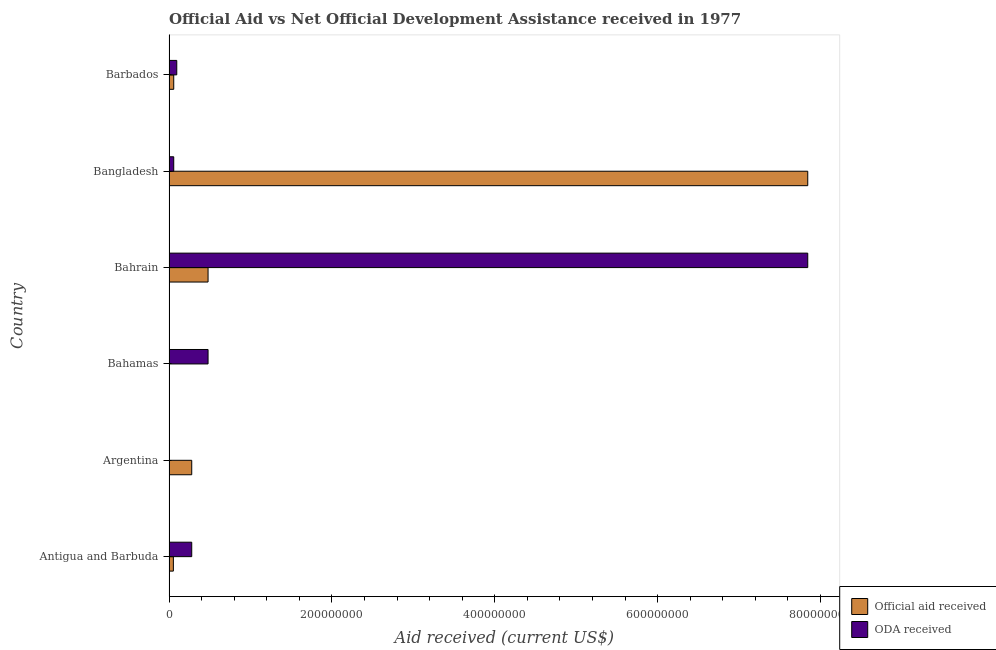How many different coloured bars are there?
Offer a very short reply. 2. How many groups of bars are there?
Your answer should be very brief. 6. How many bars are there on the 3rd tick from the bottom?
Offer a very short reply. 2. What is the label of the 4th group of bars from the top?
Provide a succinct answer. Bahamas. What is the oda received in Argentina?
Make the answer very short. 4.70e+05. Across all countries, what is the maximum official aid received?
Offer a terse response. 7.84e+08. Across all countries, what is the minimum oda received?
Provide a succinct answer. 4.70e+05. In which country was the official aid received maximum?
Offer a terse response. Bangladesh. In which country was the official aid received minimum?
Make the answer very short. Bahamas. What is the total official aid received in the graph?
Your answer should be very brief. 8.72e+08. What is the difference between the official aid received in Bangladesh and that in Barbados?
Make the answer very short. 7.79e+08. What is the difference between the official aid received in Antigua and Barbuda and the oda received in Bahamas?
Your answer should be compact. -4.26e+07. What is the average oda received per country?
Make the answer very short. 1.46e+08. What is the difference between the official aid received and oda received in Barbados?
Ensure brevity in your answer.  -3.71e+06. In how many countries, is the oda received greater than 680000000 US$?
Provide a succinct answer. 1. What is the ratio of the official aid received in Argentina to that in Bahamas?
Offer a terse response. 59.4. Is the oda received in Bahamas less than that in Barbados?
Ensure brevity in your answer.  No. Is the difference between the official aid received in Antigua and Barbuda and Bangladesh greater than the difference between the oda received in Antigua and Barbuda and Bangladesh?
Offer a terse response. No. What is the difference between the highest and the second highest oda received?
Your response must be concise. 7.36e+08. What is the difference between the highest and the lowest official aid received?
Offer a very short reply. 7.84e+08. What does the 1st bar from the top in Antigua and Barbuda represents?
Keep it short and to the point. ODA received. What does the 1st bar from the bottom in Barbados represents?
Your answer should be compact. Official aid received. Are all the bars in the graph horizontal?
Provide a short and direct response. Yes. How many countries are there in the graph?
Your answer should be compact. 6. What is the difference between two consecutive major ticks on the X-axis?
Ensure brevity in your answer.  2.00e+08. Are the values on the major ticks of X-axis written in scientific E-notation?
Make the answer very short. No. Does the graph contain grids?
Provide a succinct answer. No. Where does the legend appear in the graph?
Keep it short and to the point. Bottom right. How many legend labels are there?
Your answer should be compact. 2. How are the legend labels stacked?
Provide a short and direct response. Vertical. What is the title of the graph?
Offer a terse response. Official Aid vs Net Official Development Assistance received in 1977 . Does "Net savings(excluding particulate emission damage)" appear as one of the legend labels in the graph?
Provide a short and direct response. No. What is the label or title of the X-axis?
Ensure brevity in your answer.  Aid received (current US$). What is the Aid received (current US$) of Official aid received in Antigua and Barbuda?
Provide a short and direct response. 5.38e+06. What is the Aid received (current US$) in ODA received in Antigua and Barbuda?
Provide a short and direct response. 2.79e+07. What is the Aid received (current US$) in Official aid received in Argentina?
Offer a terse response. 2.79e+07. What is the Aid received (current US$) of ODA received in Argentina?
Make the answer very short. 4.70e+05. What is the Aid received (current US$) of Official aid received in Bahamas?
Your answer should be very brief. 4.70e+05. What is the Aid received (current US$) of ODA received in Bahamas?
Your response must be concise. 4.80e+07. What is the Aid received (current US$) of Official aid received in Bahrain?
Provide a short and direct response. 4.80e+07. What is the Aid received (current US$) of ODA received in Bahrain?
Your response must be concise. 7.84e+08. What is the Aid received (current US$) in Official aid received in Bangladesh?
Give a very brief answer. 7.84e+08. What is the Aid received (current US$) in ODA received in Bangladesh?
Ensure brevity in your answer.  5.82e+06. What is the Aid received (current US$) of Official aid received in Barbados?
Make the answer very short. 5.82e+06. What is the Aid received (current US$) in ODA received in Barbados?
Give a very brief answer. 9.53e+06. Across all countries, what is the maximum Aid received (current US$) in Official aid received?
Your response must be concise. 7.84e+08. Across all countries, what is the maximum Aid received (current US$) of ODA received?
Offer a terse response. 7.84e+08. Across all countries, what is the minimum Aid received (current US$) in ODA received?
Your answer should be very brief. 4.70e+05. What is the total Aid received (current US$) in Official aid received in the graph?
Provide a succinct answer. 8.72e+08. What is the total Aid received (current US$) in ODA received in the graph?
Give a very brief answer. 8.76e+08. What is the difference between the Aid received (current US$) in Official aid received in Antigua and Barbuda and that in Argentina?
Your answer should be very brief. -2.25e+07. What is the difference between the Aid received (current US$) of ODA received in Antigua and Barbuda and that in Argentina?
Provide a short and direct response. 2.74e+07. What is the difference between the Aid received (current US$) of Official aid received in Antigua and Barbuda and that in Bahamas?
Offer a very short reply. 4.91e+06. What is the difference between the Aid received (current US$) in ODA received in Antigua and Barbuda and that in Bahamas?
Offer a very short reply. -2.00e+07. What is the difference between the Aid received (current US$) in Official aid received in Antigua and Barbuda and that in Bahrain?
Provide a short and direct response. -4.26e+07. What is the difference between the Aid received (current US$) of ODA received in Antigua and Barbuda and that in Bahrain?
Keep it short and to the point. -7.56e+08. What is the difference between the Aid received (current US$) of Official aid received in Antigua and Barbuda and that in Bangladesh?
Your response must be concise. -7.79e+08. What is the difference between the Aid received (current US$) of ODA received in Antigua and Barbuda and that in Bangladesh?
Keep it short and to the point. 2.21e+07. What is the difference between the Aid received (current US$) of Official aid received in Antigua and Barbuda and that in Barbados?
Provide a succinct answer. -4.40e+05. What is the difference between the Aid received (current US$) of ODA received in Antigua and Barbuda and that in Barbados?
Your answer should be very brief. 1.84e+07. What is the difference between the Aid received (current US$) in Official aid received in Argentina and that in Bahamas?
Offer a very short reply. 2.74e+07. What is the difference between the Aid received (current US$) of ODA received in Argentina and that in Bahamas?
Ensure brevity in your answer.  -4.75e+07. What is the difference between the Aid received (current US$) of Official aid received in Argentina and that in Bahrain?
Your answer should be compact. -2.00e+07. What is the difference between the Aid received (current US$) of ODA received in Argentina and that in Bahrain?
Provide a short and direct response. -7.84e+08. What is the difference between the Aid received (current US$) of Official aid received in Argentina and that in Bangladesh?
Offer a very short reply. -7.56e+08. What is the difference between the Aid received (current US$) in ODA received in Argentina and that in Bangladesh?
Provide a succinct answer. -5.35e+06. What is the difference between the Aid received (current US$) in Official aid received in Argentina and that in Barbados?
Ensure brevity in your answer.  2.21e+07. What is the difference between the Aid received (current US$) in ODA received in Argentina and that in Barbados?
Make the answer very short. -9.06e+06. What is the difference between the Aid received (current US$) in Official aid received in Bahamas and that in Bahrain?
Provide a short and direct response. -4.75e+07. What is the difference between the Aid received (current US$) in ODA received in Bahamas and that in Bahrain?
Provide a short and direct response. -7.36e+08. What is the difference between the Aid received (current US$) of Official aid received in Bahamas and that in Bangladesh?
Offer a terse response. -7.84e+08. What is the difference between the Aid received (current US$) in ODA received in Bahamas and that in Bangladesh?
Provide a short and direct response. 4.21e+07. What is the difference between the Aid received (current US$) in Official aid received in Bahamas and that in Barbados?
Your answer should be very brief. -5.35e+06. What is the difference between the Aid received (current US$) of ODA received in Bahamas and that in Barbados?
Ensure brevity in your answer.  3.84e+07. What is the difference between the Aid received (current US$) in Official aid received in Bahrain and that in Bangladesh?
Your answer should be very brief. -7.36e+08. What is the difference between the Aid received (current US$) of ODA received in Bahrain and that in Bangladesh?
Your response must be concise. 7.79e+08. What is the difference between the Aid received (current US$) of Official aid received in Bahrain and that in Barbados?
Your answer should be compact. 4.21e+07. What is the difference between the Aid received (current US$) of ODA received in Bahrain and that in Barbados?
Provide a short and direct response. 7.75e+08. What is the difference between the Aid received (current US$) in Official aid received in Bangladesh and that in Barbados?
Your answer should be very brief. 7.79e+08. What is the difference between the Aid received (current US$) of ODA received in Bangladesh and that in Barbados?
Give a very brief answer. -3.71e+06. What is the difference between the Aid received (current US$) in Official aid received in Antigua and Barbuda and the Aid received (current US$) in ODA received in Argentina?
Give a very brief answer. 4.91e+06. What is the difference between the Aid received (current US$) in Official aid received in Antigua and Barbuda and the Aid received (current US$) in ODA received in Bahamas?
Your answer should be compact. -4.26e+07. What is the difference between the Aid received (current US$) in Official aid received in Antigua and Barbuda and the Aid received (current US$) in ODA received in Bahrain?
Your response must be concise. -7.79e+08. What is the difference between the Aid received (current US$) in Official aid received in Antigua and Barbuda and the Aid received (current US$) in ODA received in Bangladesh?
Ensure brevity in your answer.  -4.40e+05. What is the difference between the Aid received (current US$) of Official aid received in Antigua and Barbuda and the Aid received (current US$) of ODA received in Barbados?
Provide a succinct answer. -4.15e+06. What is the difference between the Aid received (current US$) of Official aid received in Argentina and the Aid received (current US$) of ODA received in Bahamas?
Offer a very short reply. -2.00e+07. What is the difference between the Aid received (current US$) in Official aid received in Argentina and the Aid received (current US$) in ODA received in Bahrain?
Keep it short and to the point. -7.56e+08. What is the difference between the Aid received (current US$) of Official aid received in Argentina and the Aid received (current US$) of ODA received in Bangladesh?
Your response must be concise. 2.21e+07. What is the difference between the Aid received (current US$) of Official aid received in Argentina and the Aid received (current US$) of ODA received in Barbados?
Provide a succinct answer. 1.84e+07. What is the difference between the Aid received (current US$) of Official aid received in Bahamas and the Aid received (current US$) of ODA received in Bahrain?
Your answer should be compact. -7.84e+08. What is the difference between the Aid received (current US$) in Official aid received in Bahamas and the Aid received (current US$) in ODA received in Bangladesh?
Your answer should be compact. -5.35e+06. What is the difference between the Aid received (current US$) in Official aid received in Bahamas and the Aid received (current US$) in ODA received in Barbados?
Provide a short and direct response. -9.06e+06. What is the difference between the Aid received (current US$) of Official aid received in Bahrain and the Aid received (current US$) of ODA received in Bangladesh?
Make the answer very short. 4.21e+07. What is the difference between the Aid received (current US$) in Official aid received in Bahrain and the Aid received (current US$) in ODA received in Barbados?
Make the answer very short. 3.84e+07. What is the difference between the Aid received (current US$) in Official aid received in Bangladesh and the Aid received (current US$) in ODA received in Barbados?
Your answer should be very brief. 7.75e+08. What is the average Aid received (current US$) in Official aid received per country?
Your answer should be very brief. 1.45e+08. What is the average Aid received (current US$) of ODA received per country?
Provide a succinct answer. 1.46e+08. What is the difference between the Aid received (current US$) of Official aid received and Aid received (current US$) of ODA received in Antigua and Barbuda?
Offer a very short reply. -2.25e+07. What is the difference between the Aid received (current US$) of Official aid received and Aid received (current US$) of ODA received in Argentina?
Your answer should be very brief. 2.74e+07. What is the difference between the Aid received (current US$) in Official aid received and Aid received (current US$) in ODA received in Bahamas?
Keep it short and to the point. -4.75e+07. What is the difference between the Aid received (current US$) in Official aid received and Aid received (current US$) in ODA received in Bahrain?
Provide a short and direct response. -7.36e+08. What is the difference between the Aid received (current US$) in Official aid received and Aid received (current US$) in ODA received in Bangladesh?
Your answer should be compact. 7.79e+08. What is the difference between the Aid received (current US$) in Official aid received and Aid received (current US$) in ODA received in Barbados?
Offer a terse response. -3.71e+06. What is the ratio of the Aid received (current US$) in Official aid received in Antigua and Barbuda to that in Argentina?
Provide a succinct answer. 0.19. What is the ratio of the Aid received (current US$) in ODA received in Antigua and Barbuda to that in Argentina?
Offer a very short reply. 59.4. What is the ratio of the Aid received (current US$) of Official aid received in Antigua and Barbuda to that in Bahamas?
Provide a short and direct response. 11.45. What is the ratio of the Aid received (current US$) in ODA received in Antigua and Barbuda to that in Bahamas?
Provide a short and direct response. 0.58. What is the ratio of the Aid received (current US$) in Official aid received in Antigua and Barbuda to that in Bahrain?
Make the answer very short. 0.11. What is the ratio of the Aid received (current US$) in ODA received in Antigua and Barbuda to that in Bahrain?
Keep it short and to the point. 0.04. What is the ratio of the Aid received (current US$) in Official aid received in Antigua and Barbuda to that in Bangladesh?
Give a very brief answer. 0.01. What is the ratio of the Aid received (current US$) in ODA received in Antigua and Barbuda to that in Bangladesh?
Your answer should be very brief. 4.8. What is the ratio of the Aid received (current US$) in Official aid received in Antigua and Barbuda to that in Barbados?
Your answer should be very brief. 0.92. What is the ratio of the Aid received (current US$) of ODA received in Antigua and Barbuda to that in Barbados?
Your answer should be very brief. 2.93. What is the ratio of the Aid received (current US$) in Official aid received in Argentina to that in Bahamas?
Your answer should be compact. 59.4. What is the ratio of the Aid received (current US$) in ODA received in Argentina to that in Bahamas?
Provide a succinct answer. 0.01. What is the ratio of the Aid received (current US$) in Official aid received in Argentina to that in Bahrain?
Your response must be concise. 0.58. What is the ratio of the Aid received (current US$) of ODA received in Argentina to that in Bahrain?
Offer a very short reply. 0. What is the ratio of the Aid received (current US$) in Official aid received in Argentina to that in Bangladesh?
Your answer should be very brief. 0.04. What is the ratio of the Aid received (current US$) of ODA received in Argentina to that in Bangladesh?
Make the answer very short. 0.08. What is the ratio of the Aid received (current US$) of Official aid received in Argentina to that in Barbados?
Your response must be concise. 4.8. What is the ratio of the Aid received (current US$) of ODA received in Argentina to that in Barbados?
Make the answer very short. 0.05. What is the ratio of the Aid received (current US$) of Official aid received in Bahamas to that in Bahrain?
Provide a succinct answer. 0.01. What is the ratio of the Aid received (current US$) of ODA received in Bahamas to that in Bahrain?
Make the answer very short. 0.06. What is the ratio of the Aid received (current US$) in Official aid received in Bahamas to that in Bangladesh?
Provide a short and direct response. 0. What is the ratio of the Aid received (current US$) of ODA received in Bahamas to that in Bangladesh?
Keep it short and to the point. 8.24. What is the ratio of the Aid received (current US$) in Official aid received in Bahamas to that in Barbados?
Your response must be concise. 0.08. What is the ratio of the Aid received (current US$) of ODA received in Bahamas to that in Barbados?
Ensure brevity in your answer.  5.03. What is the ratio of the Aid received (current US$) of Official aid received in Bahrain to that in Bangladesh?
Give a very brief answer. 0.06. What is the ratio of the Aid received (current US$) in ODA received in Bahrain to that in Bangladesh?
Keep it short and to the point. 134.77. What is the ratio of the Aid received (current US$) of Official aid received in Bahrain to that in Barbados?
Make the answer very short. 8.24. What is the ratio of the Aid received (current US$) of ODA received in Bahrain to that in Barbados?
Keep it short and to the point. 82.3. What is the ratio of the Aid received (current US$) in Official aid received in Bangladesh to that in Barbados?
Give a very brief answer. 134.77. What is the ratio of the Aid received (current US$) of ODA received in Bangladesh to that in Barbados?
Ensure brevity in your answer.  0.61. What is the difference between the highest and the second highest Aid received (current US$) in Official aid received?
Give a very brief answer. 7.36e+08. What is the difference between the highest and the second highest Aid received (current US$) in ODA received?
Keep it short and to the point. 7.36e+08. What is the difference between the highest and the lowest Aid received (current US$) of Official aid received?
Make the answer very short. 7.84e+08. What is the difference between the highest and the lowest Aid received (current US$) in ODA received?
Your response must be concise. 7.84e+08. 